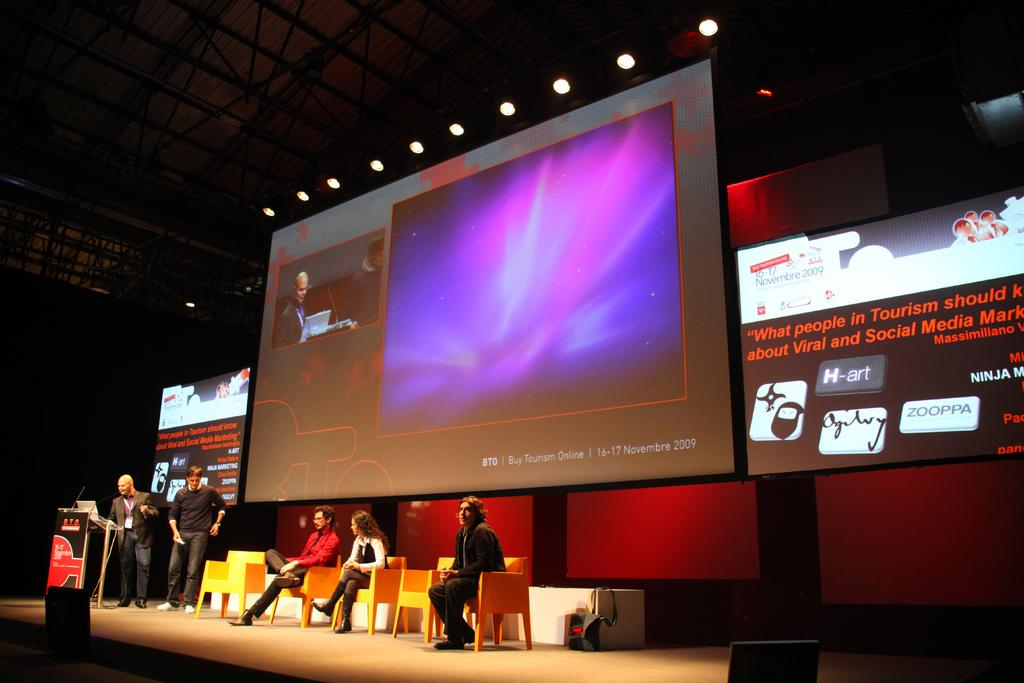<image>
Relay a brief, clear account of the picture shown. A group of people sitting on stage underneath a buy tourism online slide. 